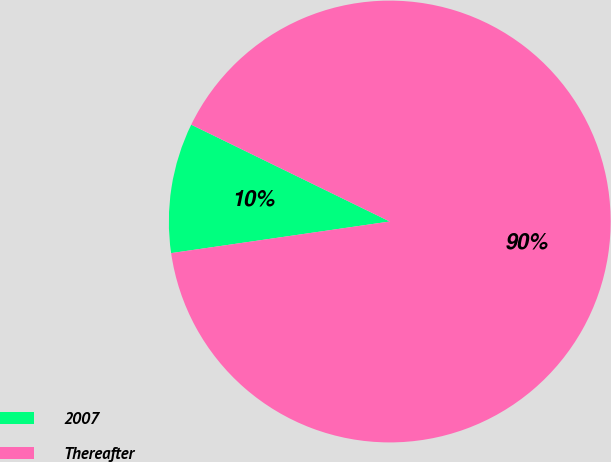<chart> <loc_0><loc_0><loc_500><loc_500><pie_chart><fcel>2007<fcel>Thereafter<nl><fcel>9.51%<fcel>90.49%<nl></chart> 